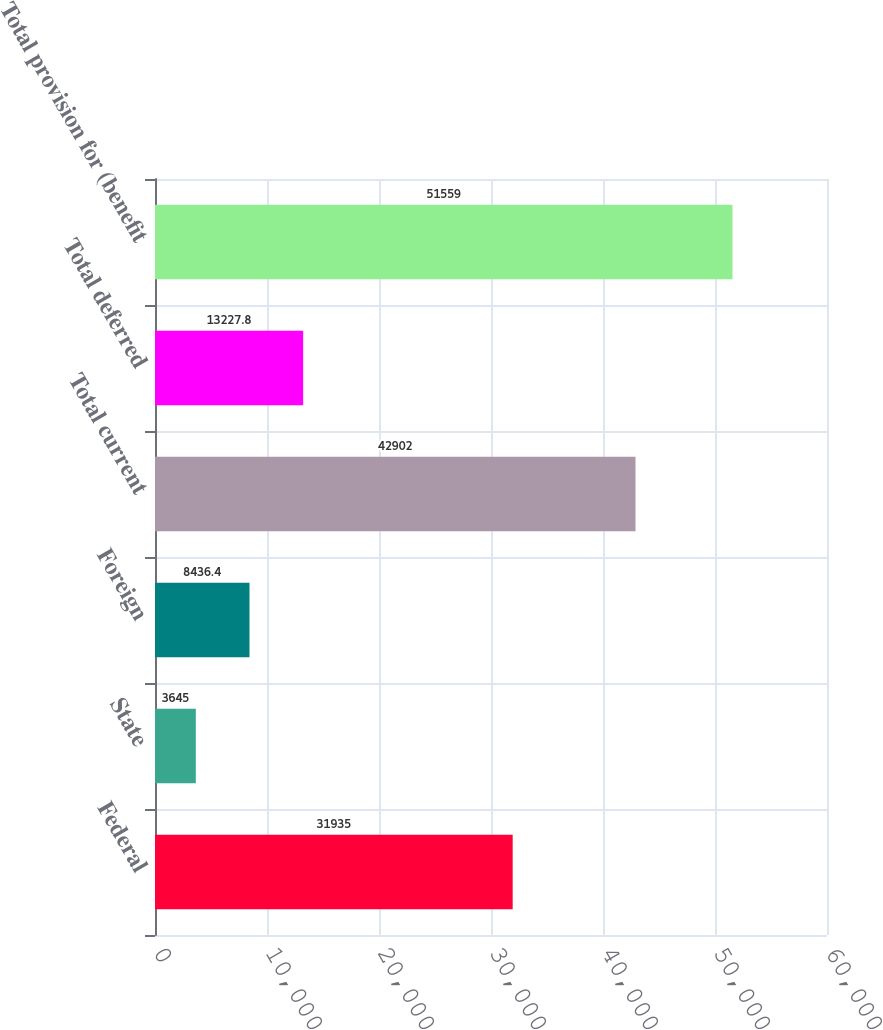<chart> <loc_0><loc_0><loc_500><loc_500><bar_chart><fcel>Federal<fcel>State<fcel>Foreign<fcel>Total current<fcel>Total deferred<fcel>Total provision for (benefit<nl><fcel>31935<fcel>3645<fcel>8436.4<fcel>42902<fcel>13227.8<fcel>51559<nl></chart> 